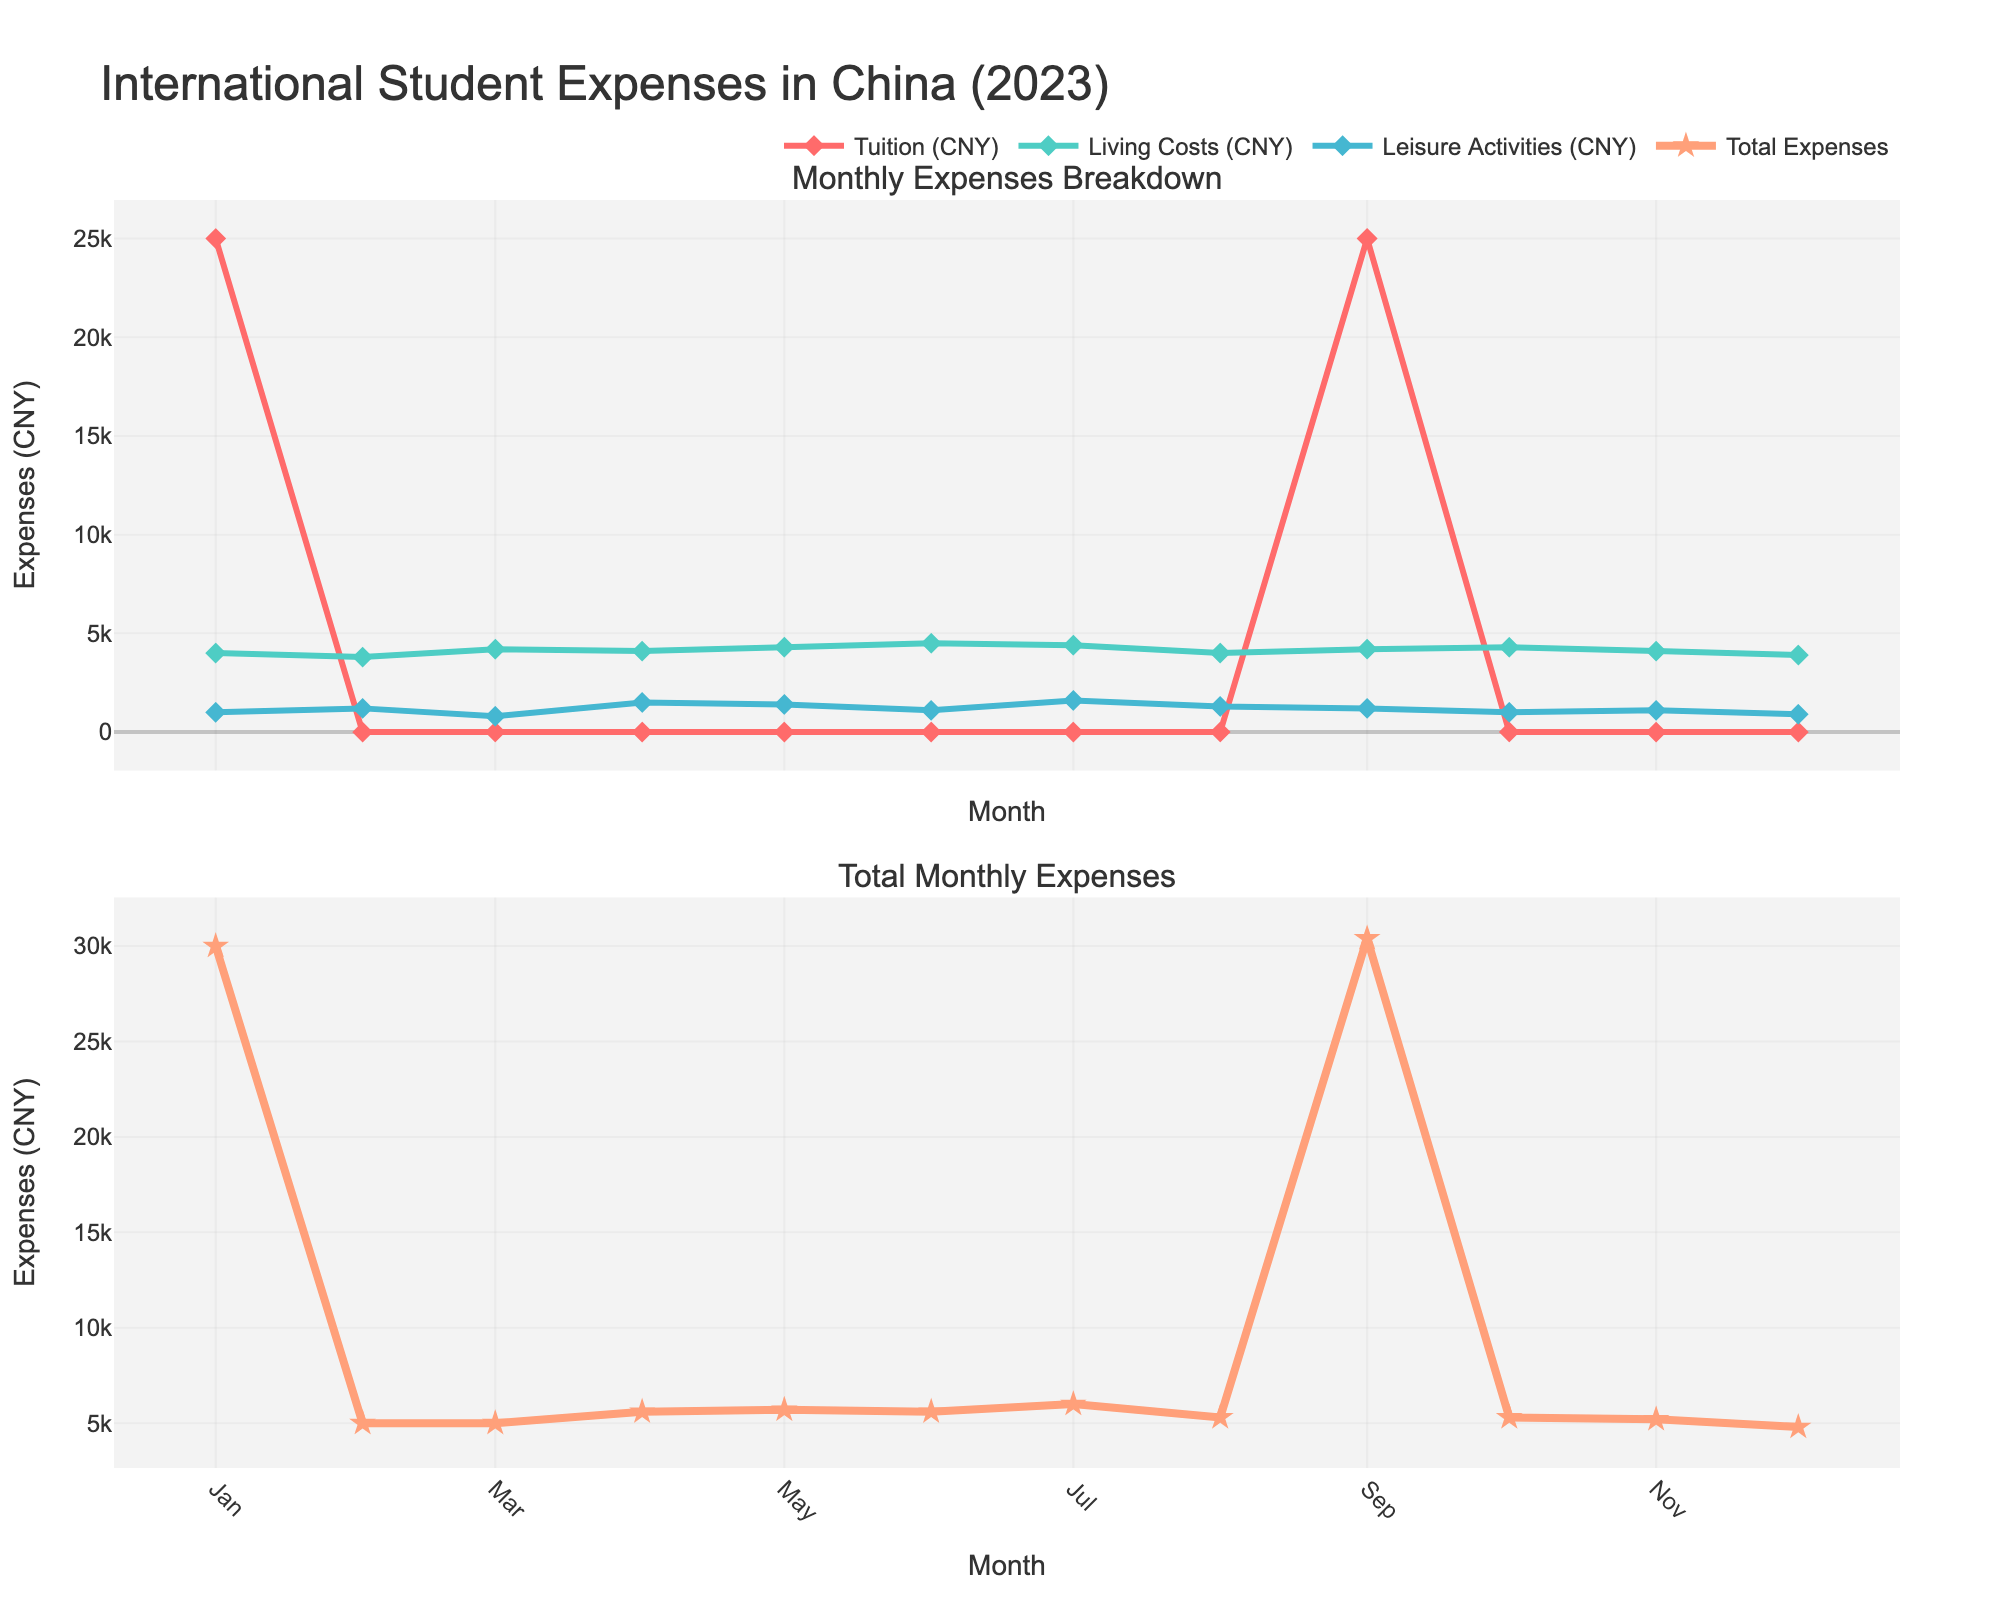What are the titles of the subplots? The titles can be found at the top of each subplot. For the first subplot, the title is "Monthly Expenses Breakdown", and for the second subplot, the title is "Total Monthly Expenses".
Answer: "Monthly Expenses Breakdown" and "Total Monthly Expenses" How many total expense categories are tracked in 2023? The total expense categories are shown by the different colored lines in the first subplot. There are 3 lines, each representing a different category: Tuition, Living Costs, and Leisure Activities.
Answer: 3 In which months are the tuition expenses non-zero? The tuition expenses are indicated by points on the red line chart in the first subplot. By observing, we see points in January and September, indicating the months when tuition expenses occurred.
Answer: January and September What is the highest total monthly expense in 2023? Total monthly expenses are shown in the second subplot by the orange line. The highest point can be found by identifying the peak of this line, which happens in January. The value at this peak is 30000 CNY.
Answer: 30000 CNY Which category showed the highest expenses in July 2023? For July, observe the three different lines in the first subplot. The green line, representing Leisure Activities, has a point at 1600 CNY, which is higher than the other categories.
Answer: Leisure Activities What is the range of living costs across the year? The range is the difference between the highest and lowest points of the light blue line in the first subplot. The highest is 4500 CNY in June, and the lowest is 3800 CNY in February. So, the range is 4500 - 3800 = 700 CNY.
Answer: 700 CNY How do leisure activities expenses in April compare to those in December? Examine the points on the yellow line for April and December in the first subplot. April has 1500 CNY and December has 900 CNY. April’s expenses are higher by 600 CNY.
Answer: April is higher by 600 CNY In which month are total expenses the lowest? Identify the lowest point on the orange line in the second subplot. This occurs in December, where total expenses are at 4800 CNY.
Answer: December How does the sum of living costs and leisure activities in October compare to the total expenses in March? First, calculate the sum of living costs and leisure activities for October: 4300 CNY + 1000 CNY = 5300 CNY. Then, observe the total expenses for March in the second subplot, which are 5000 CNY. The sum in October is higher by 300 CNY.
Answer: October is higher by 300 CNY 